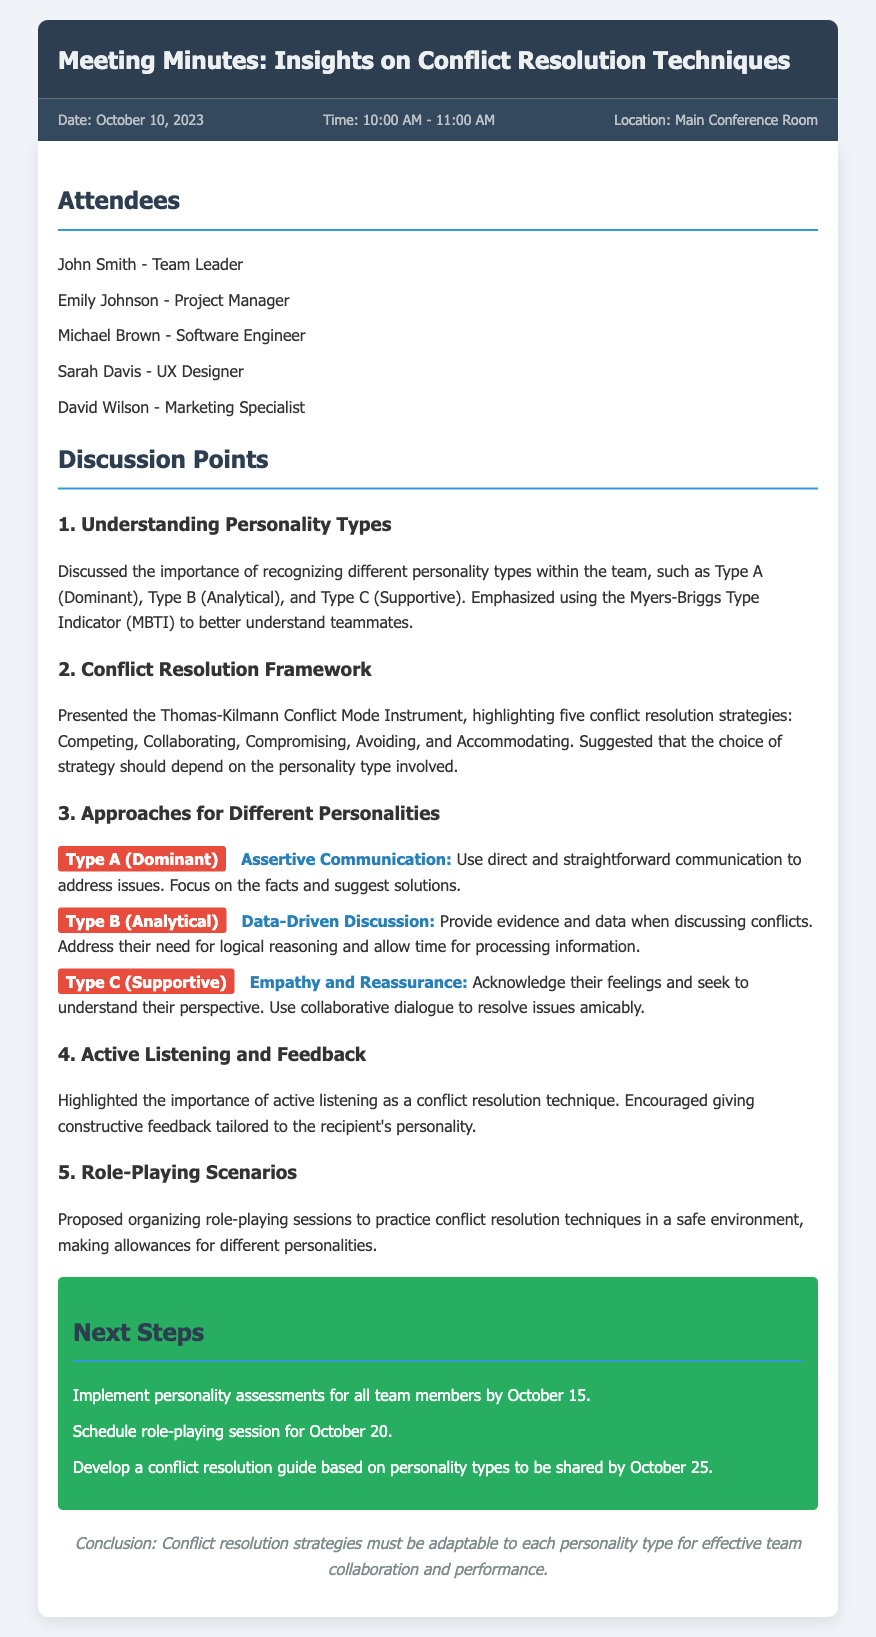what is the date of the meeting? The date of the meeting is specified in the document as October 10, 2023.
Answer: October 10, 2023 who is the team leader? The document lists John Smith as the team leader.
Answer: John Smith how many conflict resolution strategies are highlighted? The document presents five conflict resolution strategies as per the Thomas-Kilmann Conflict Mode Instrument.
Answer: Five what communication technique is suggested for Type A personalities? The document indicates that assertive communication is recommended for Type A (Dominant) personalities.
Answer: Assertive Communication what is the next step concerning personality assessments? The document states that personality assessments for all team members should be implemented by October 15.
Answer: October 15 which personality type requires data-driven discussions? According to the document, Type B (Analytical) personalities require data-driven discussions.
Answer: Type B (Analytical) what is the purpose of role-playing sessions mentioned? The purpose of role-playing sessions is to practice conflict resolution techniques in a safe environment.
Answer: Practice conflict resolution techniques how should feedback be given according to the discussion? The discussion emphasizes giving constructive feedback tailored to the recipient's personality.
Answer: Tailored to the recipient's personality 